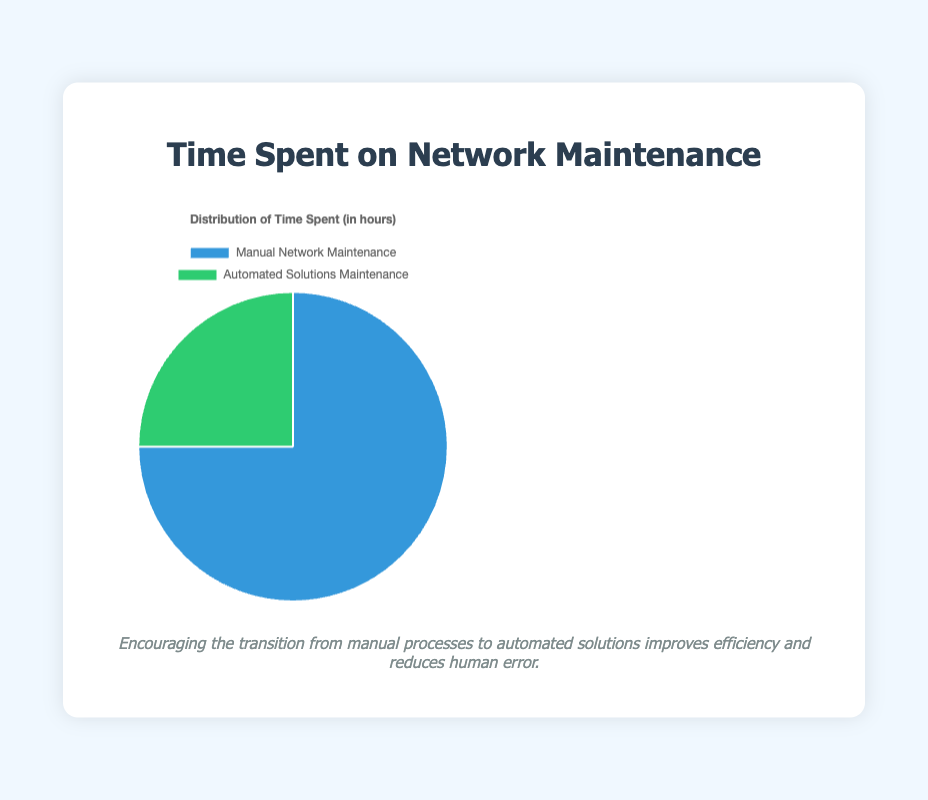Which type of maintenance consumes more time? Looking at the chart, the larger segment represents "Manual Network Maintenance" with 30 hours, which is more than "Automated Solutions Maintenance" with 10 hours.
Answer: Manual Network Maintenance What is the percentage of time spent on Automated Solutions Maintenance? Total time spent on maintenance is 40 hours. Time spent on Automated Solutions Maintenance is 10 hours. Percentage = (10/40) * 100 = 25%.
Answer: 25% How much more time is spent on Manual Network Maintenance compared to Automated Solutions Maintenance? Manual Network Maintenance takes 30 hours and Automated Solutions Maintenance takes 10 hours. The difference is 30 - 10 = 20 hours.
Answer: 20 hours Which segment is represented by a green color in the chart? Observing the chart, the green color is used to indicate "Automated Solutions Maintenance".
Answer: Automated Solutions Maintenance What is the ratio of time spent on Manual Network Maintenance to Automated Solutions Maintenance? Time spent on Manual Network Maintenance is 30 hours, and Automated Solutions Maintenance is 10 hours. The ratio is 30:10 or simplified, 3:1.
Answer: 3:1 If you were to decrease manual maintenance by 50%, what would be the new time proportion for Automated Solutions Maintenance? Decreasing manual maintenance by 50% reduces it to 15 hours. The total is now 15 + 10 = 25 hours. So, for Automated Solutions Maintenance: (10/25) * 100 = 40%.
Answer: 40% What is the difference in percentage of time spent between the two maintenance types? Manual Network Maintenance is (30/40) * 100 = 75% and Automated Solutions Maintenance is 25%. Difference = 75% - 25% = 50%.
Answer: 50% What proportion of the total maintenance time does Manual Network Maintenance constitute? Manual Network Maintenance is 30 hours out of a total of 40 hours. Proportion = 30/40 = 0.75, or 75%.
Answer: 75% How many hours would be saved if all maintenance was automated, reducing manual maintenance to zero? Since 30 hours is spent manually, and automating this would reduce it to zero, the saved hours are 30.
Answer: 30 hours 